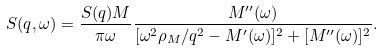Convert formula to latex. <formula><loc_0><loc_0><loc_500><loc_500>S ( q , \omega ) = \frac { S ( q ) M } { \pi \omega } \frac { M ^ { \prime \prime } ( \omega ) } { [ \omega ^ { 2 } \rho _ { M } / q ^ { 2 } - M ^ { \prime } ( \omega ) ] ^ { 2 } + [ M ^ { \prime \prime } ( \omega ) ] ^ { 2 } } .</formula> 